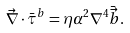Convert formula to latex. <formula><loc_0><loc_0><loc_500><loc_500>\vec { \nabla } \cdot \bar { \tau } ^ { b } = \eta \alpha ^ { 2 } \nabla ^ { 4 } \bar { \vec { b } } .</formula> 